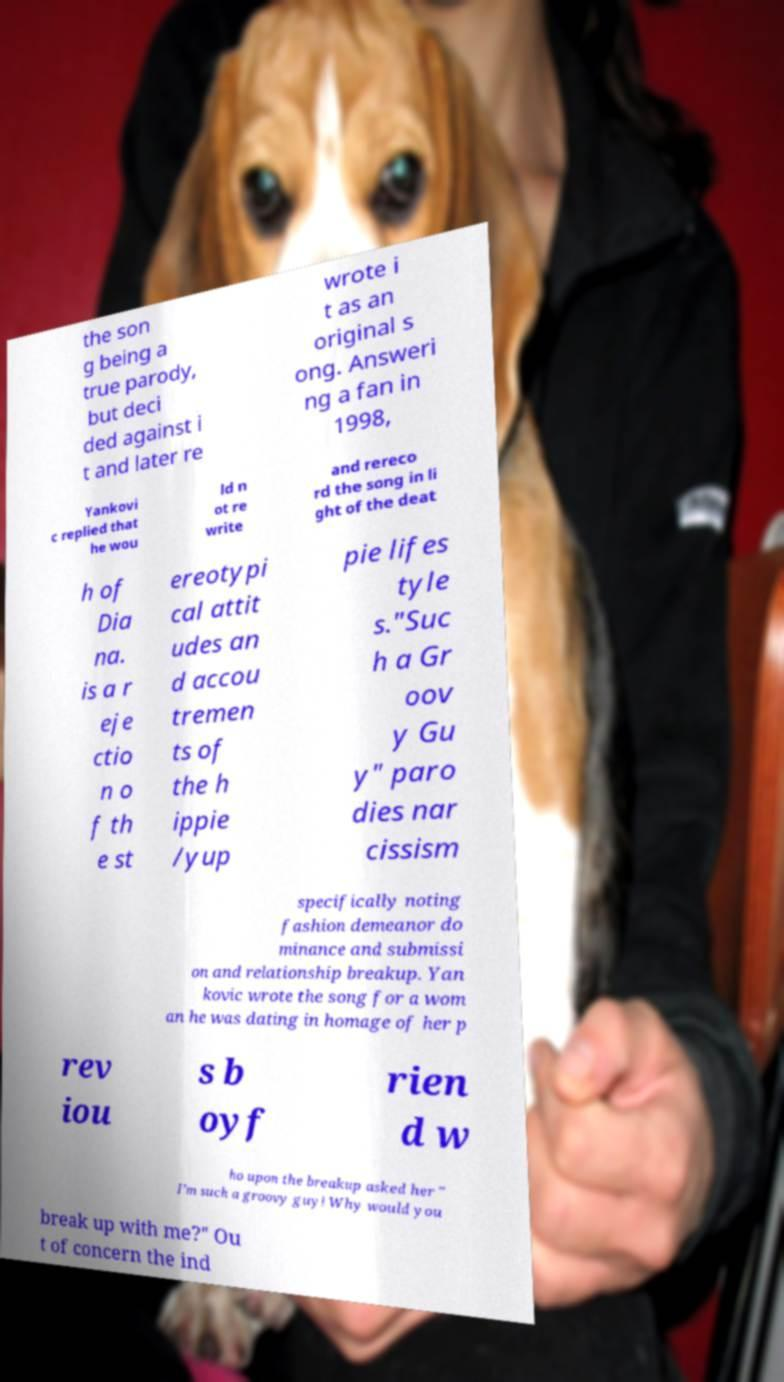Could you extract and type out the text from this image? the son g being a true parody, but deci ded against i t and later re wrote i t as an original s ong. Answeri ng a fan in 1998, Yankovi c replied that he wou ld n ot re write and rereco rd the song in li ght of the deat h of Dia na. is a r eje ctio n o f th e st ereotypi cal attit udes an d accou tremen ts of the h ippie /yup pie lifes tyle s."Suc h a Gr oov y Gu y" paro dies nar cissism specifically noting fashion demeanor do minance and submissi on and relationship breakup. Yan kovic wrote the song for a wom an he was dating in homage of her p rev iou s b oyf rien d w ho upon the breakup asked her " I’m such a groovy guy! Why would you break up with me?" Ou t of concern the ind 